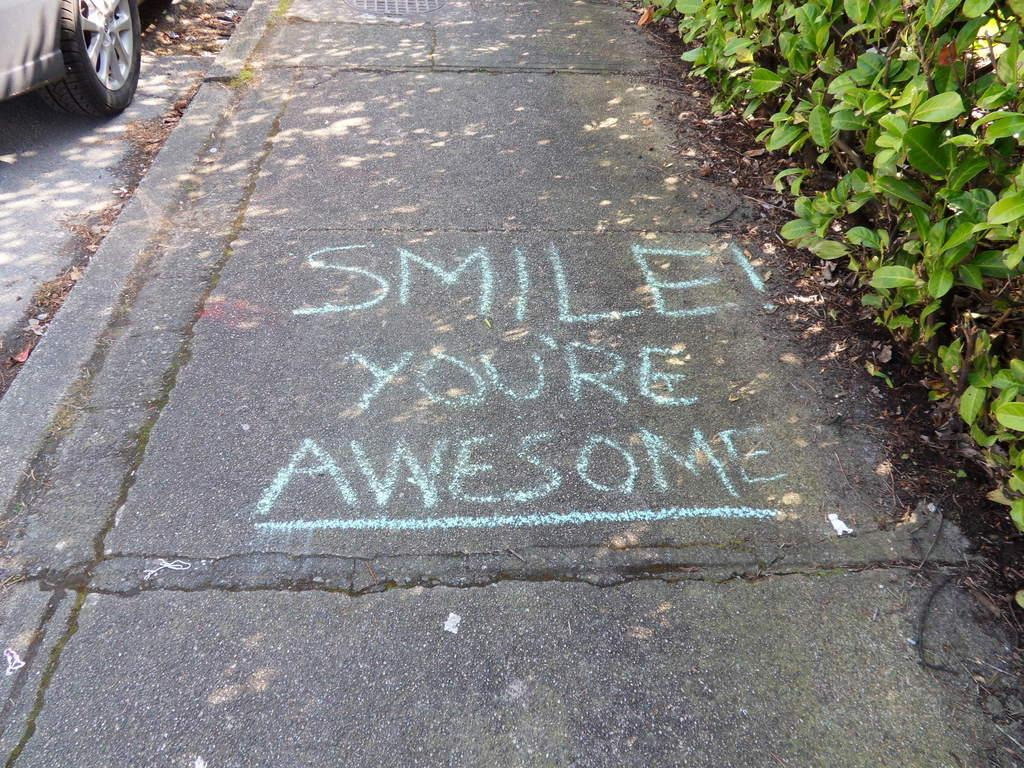What is written or displayed on the road in the image? There is text on the road in the image. What type of vegetation is on the right side of the image? There are plants on the right side of the image. What can be seen on the left side of the image? There is a vehicle on the left side of the image. Where is the vehicle located in relation to the road? The vehicle is on the road. What discovery was made by the crook in the image? There is no crook or discovery present in the image. The image features text on the road, plants on the right side, and a vehicle on the left side. 